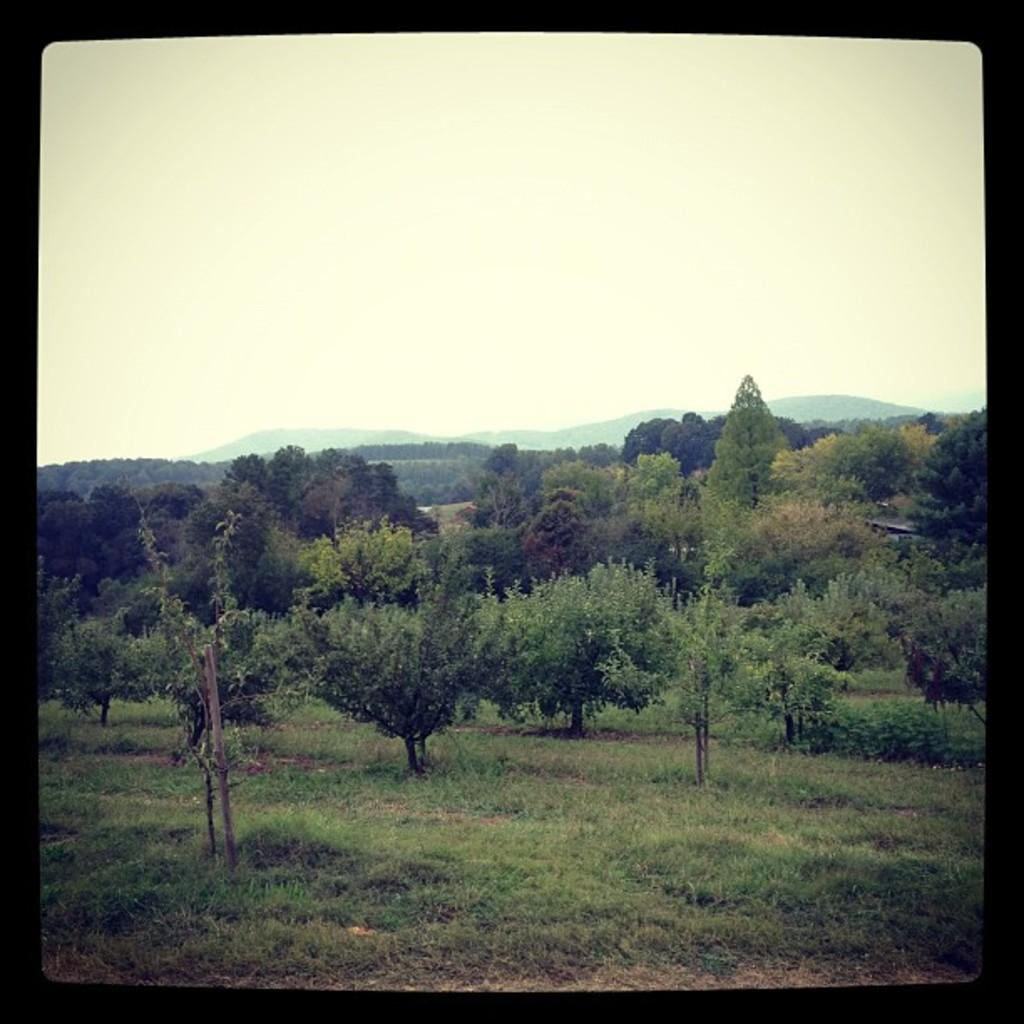What type of vegetation can be seen in the image? There are trees in the image. What is on the ground in the image? There is grass on the ground in the image. What can be seen in the distance in the image? There are mountains in the background of the image. What is visible at the top of the image? The sky is visible at the top of the image. What type of engine can be seen in the yard in the image? There is no engine or yard present in the image. How many railway tracks are visible in the image? There are no railway tracks present in the image. 